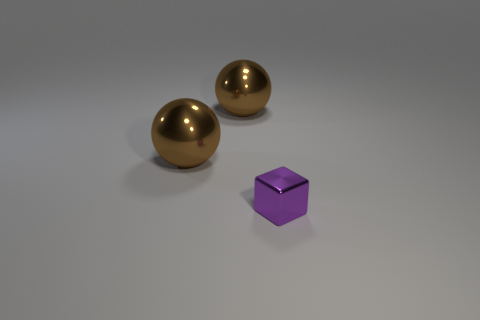Add 3 purple metal objects. How many objects exist? 6 Subtract all spheres. How many objects are left? 1 Subtract 0 red cylinders. How many objects are left? 3 Subtract all purple things. Subtract all small objects. How many objects are left? 1 Add 2 purple shiny cubes. How many purple shiny cubes are left? 3 Add 2 brown metallic things. How many brown metallic things exist? 4 